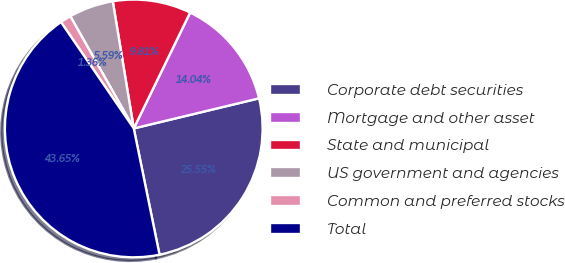<chart> <loc_0><loc_0><loc_500><loc_500><pie_chart><fcel>Corporate debt securities<fcel>Mortgage and other asset<fcel>State and municipal<fcel>US government and agencies<fcel>Common and preferred stocks<fcel>Total<nl><fcel>25.55%<fcel>14.04%<fcel>9.81%<fcel>5.59%<fcel>1.36%<fcel>43.65%<nl></chart> 